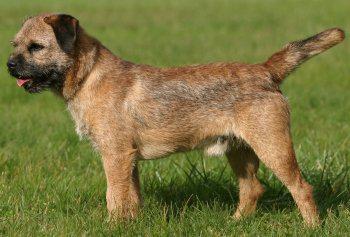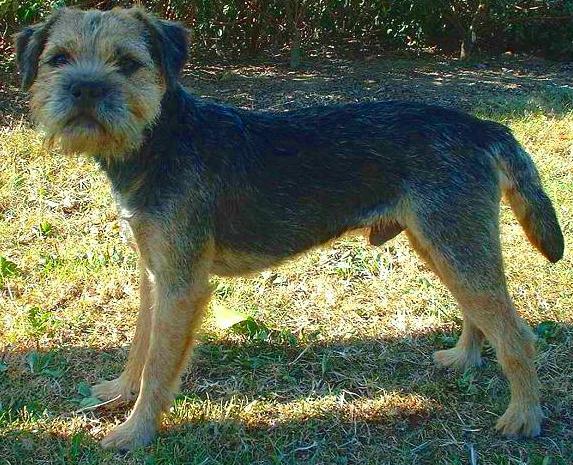The first image is the image on the left, the second image is the image on the right. Assess this claim about the two images: "Both images show dogs standing in profile with bodies and heads turned the same direction.". Correct or not? Answer yes or no. No. The first image is the image on the left, the second image is the image on the right. Given the left and right images, does the statement "The dog on the left is standing in the grass by a person." hold true? Answer yes or no. No. 